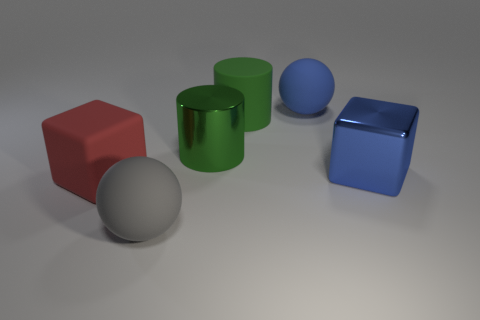Add 2 big brown shiny spheres. How many objects exist? 8 Subtract all spheres. How many objects are left? 4 Add 5 small yellow metal balls. How many small yellow metal balls exist? 5 Subtract 0 gray cylinders. How many objects are left? 6 Subtract all tiny yellow cubes. Subtract all rubber cubes. How many objects are left? 5 Add 5 blue rubber spheres. How many blue rubber spheres are left? 6 